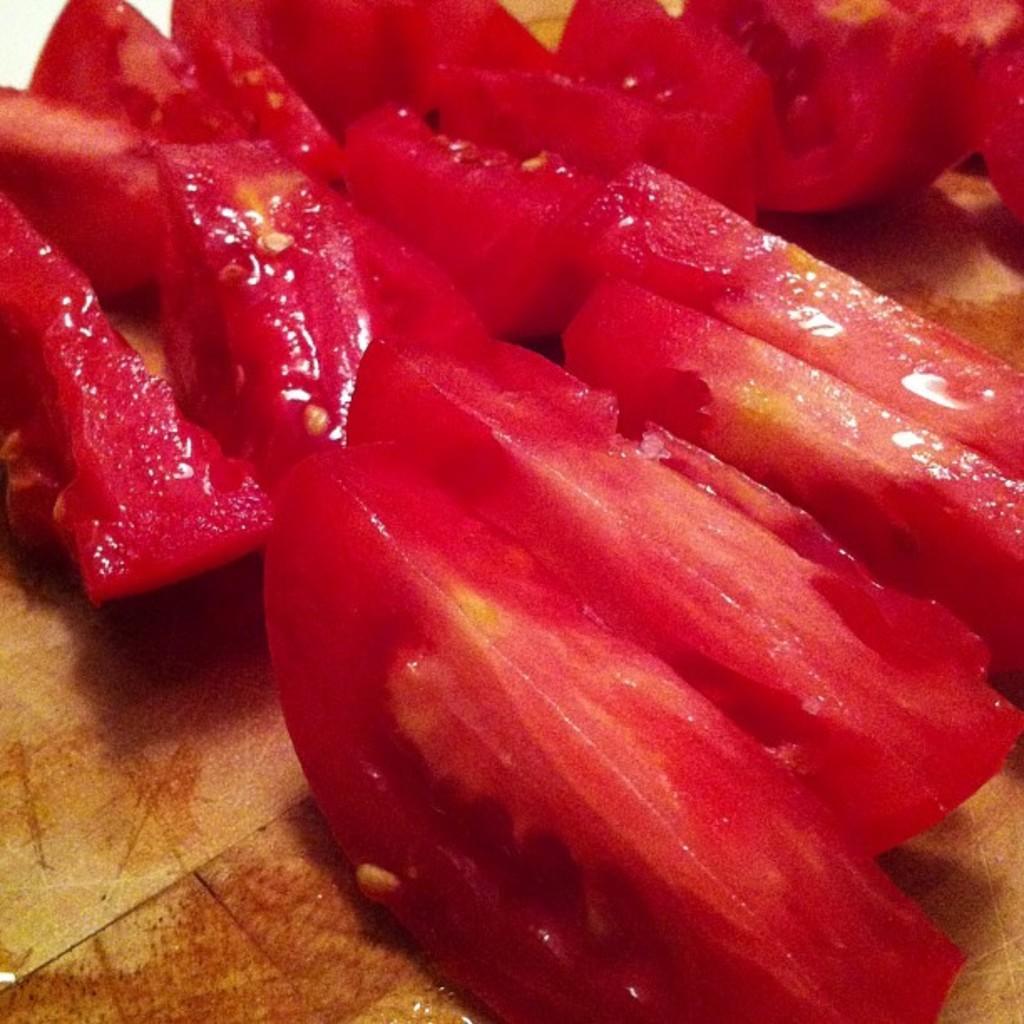Please provide a concise description of this image. In this image there is a chopping board and there are a few tomato slices on the chopping board. 